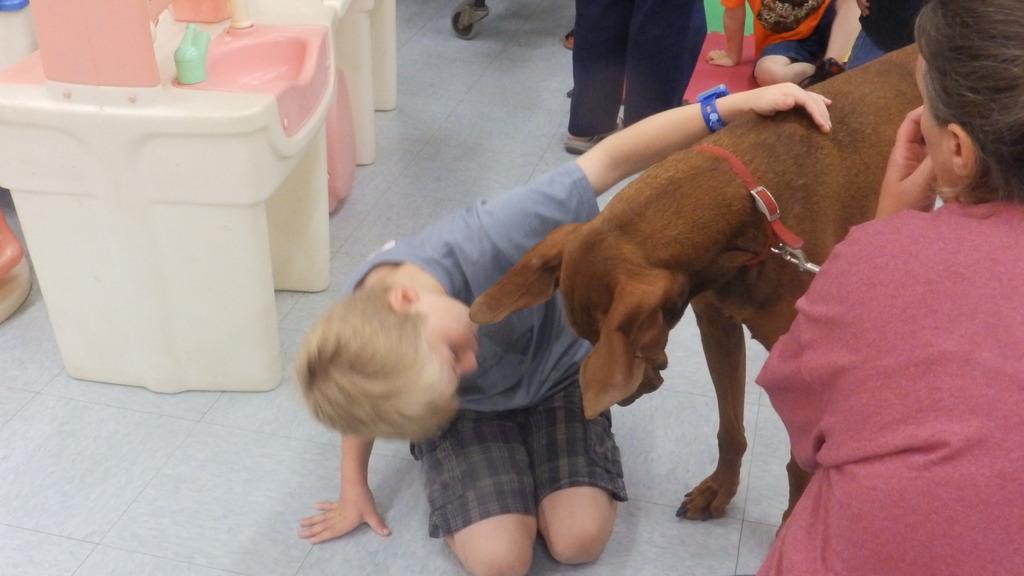Could you give a brief overview of what you see in this image? In this picture we can see boy keeping his hand on dog and in the background we can see some more persons, floor and here it is plastic table or sink. 